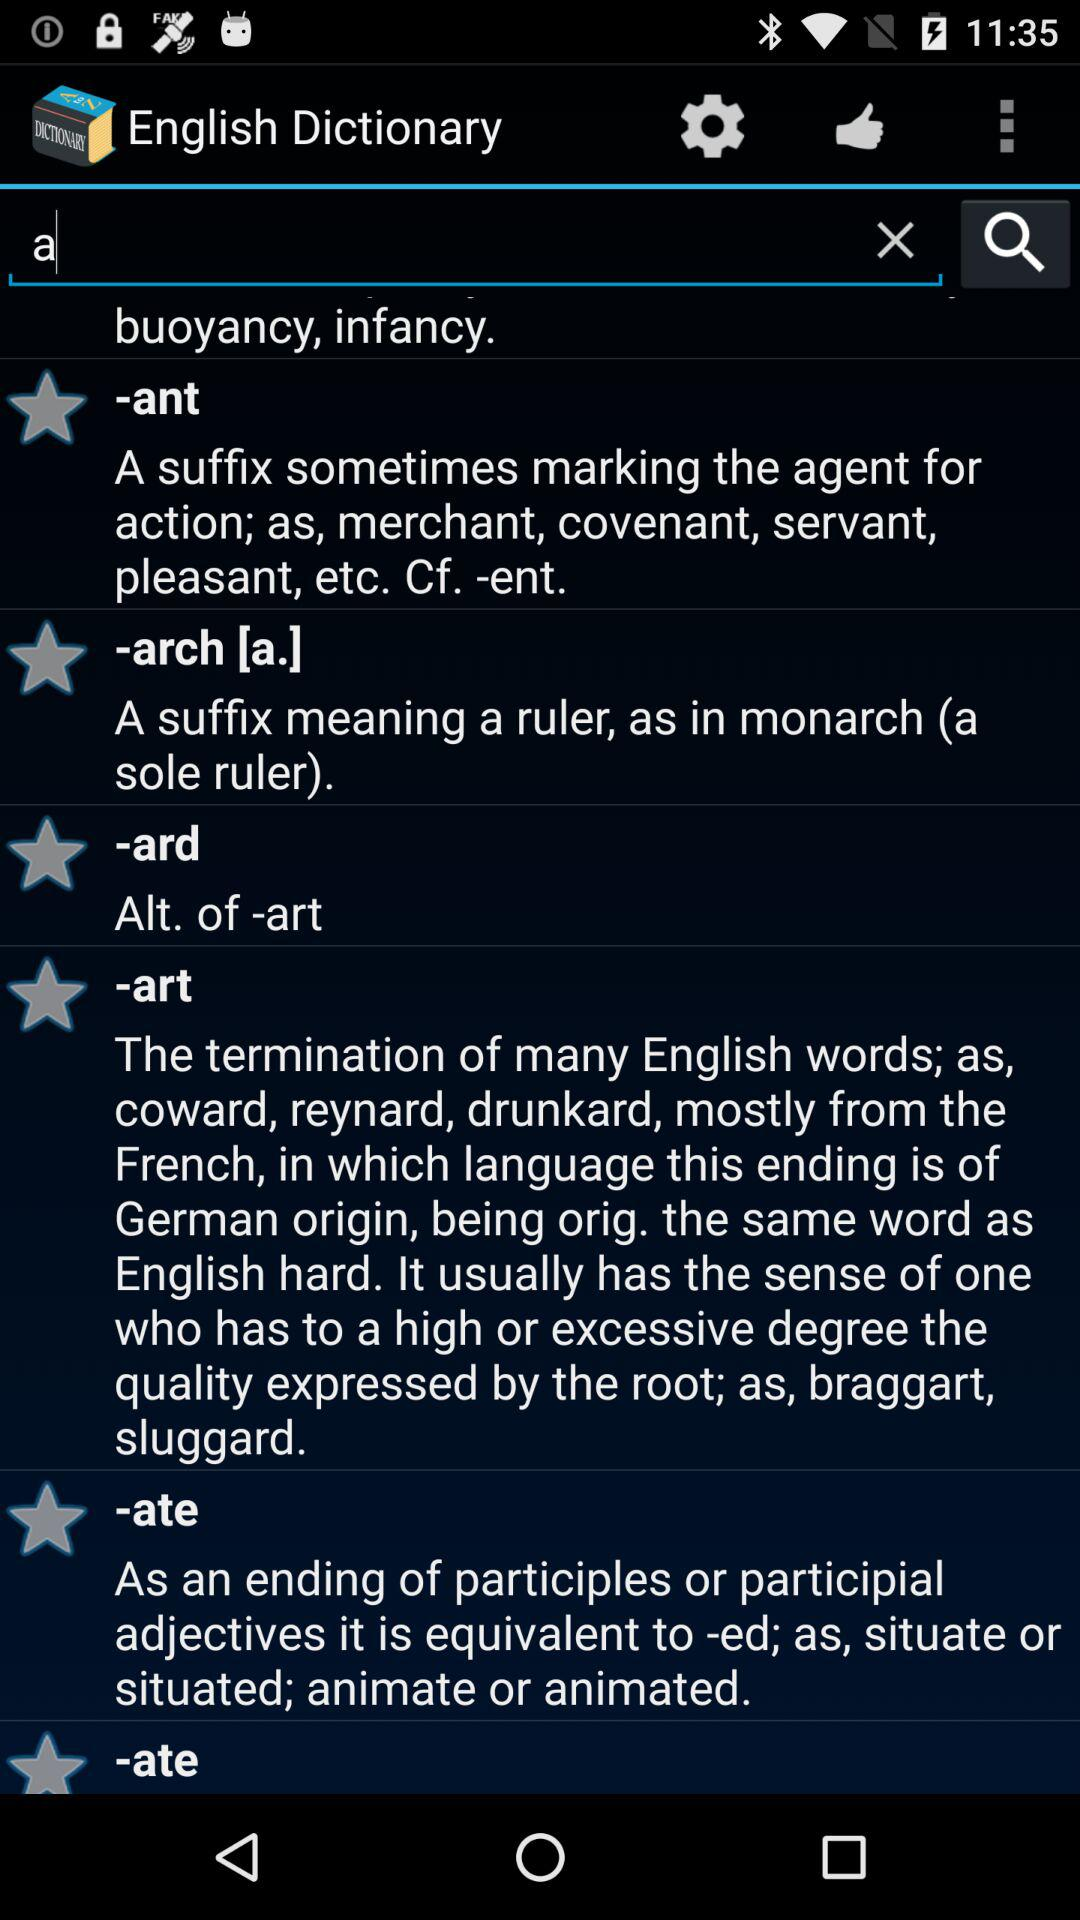What are the mentioned examples of words with the suffix "ant"? The mentioned examples of words with the suffix "ant" are merchant, covenant, servant and pleasant. 